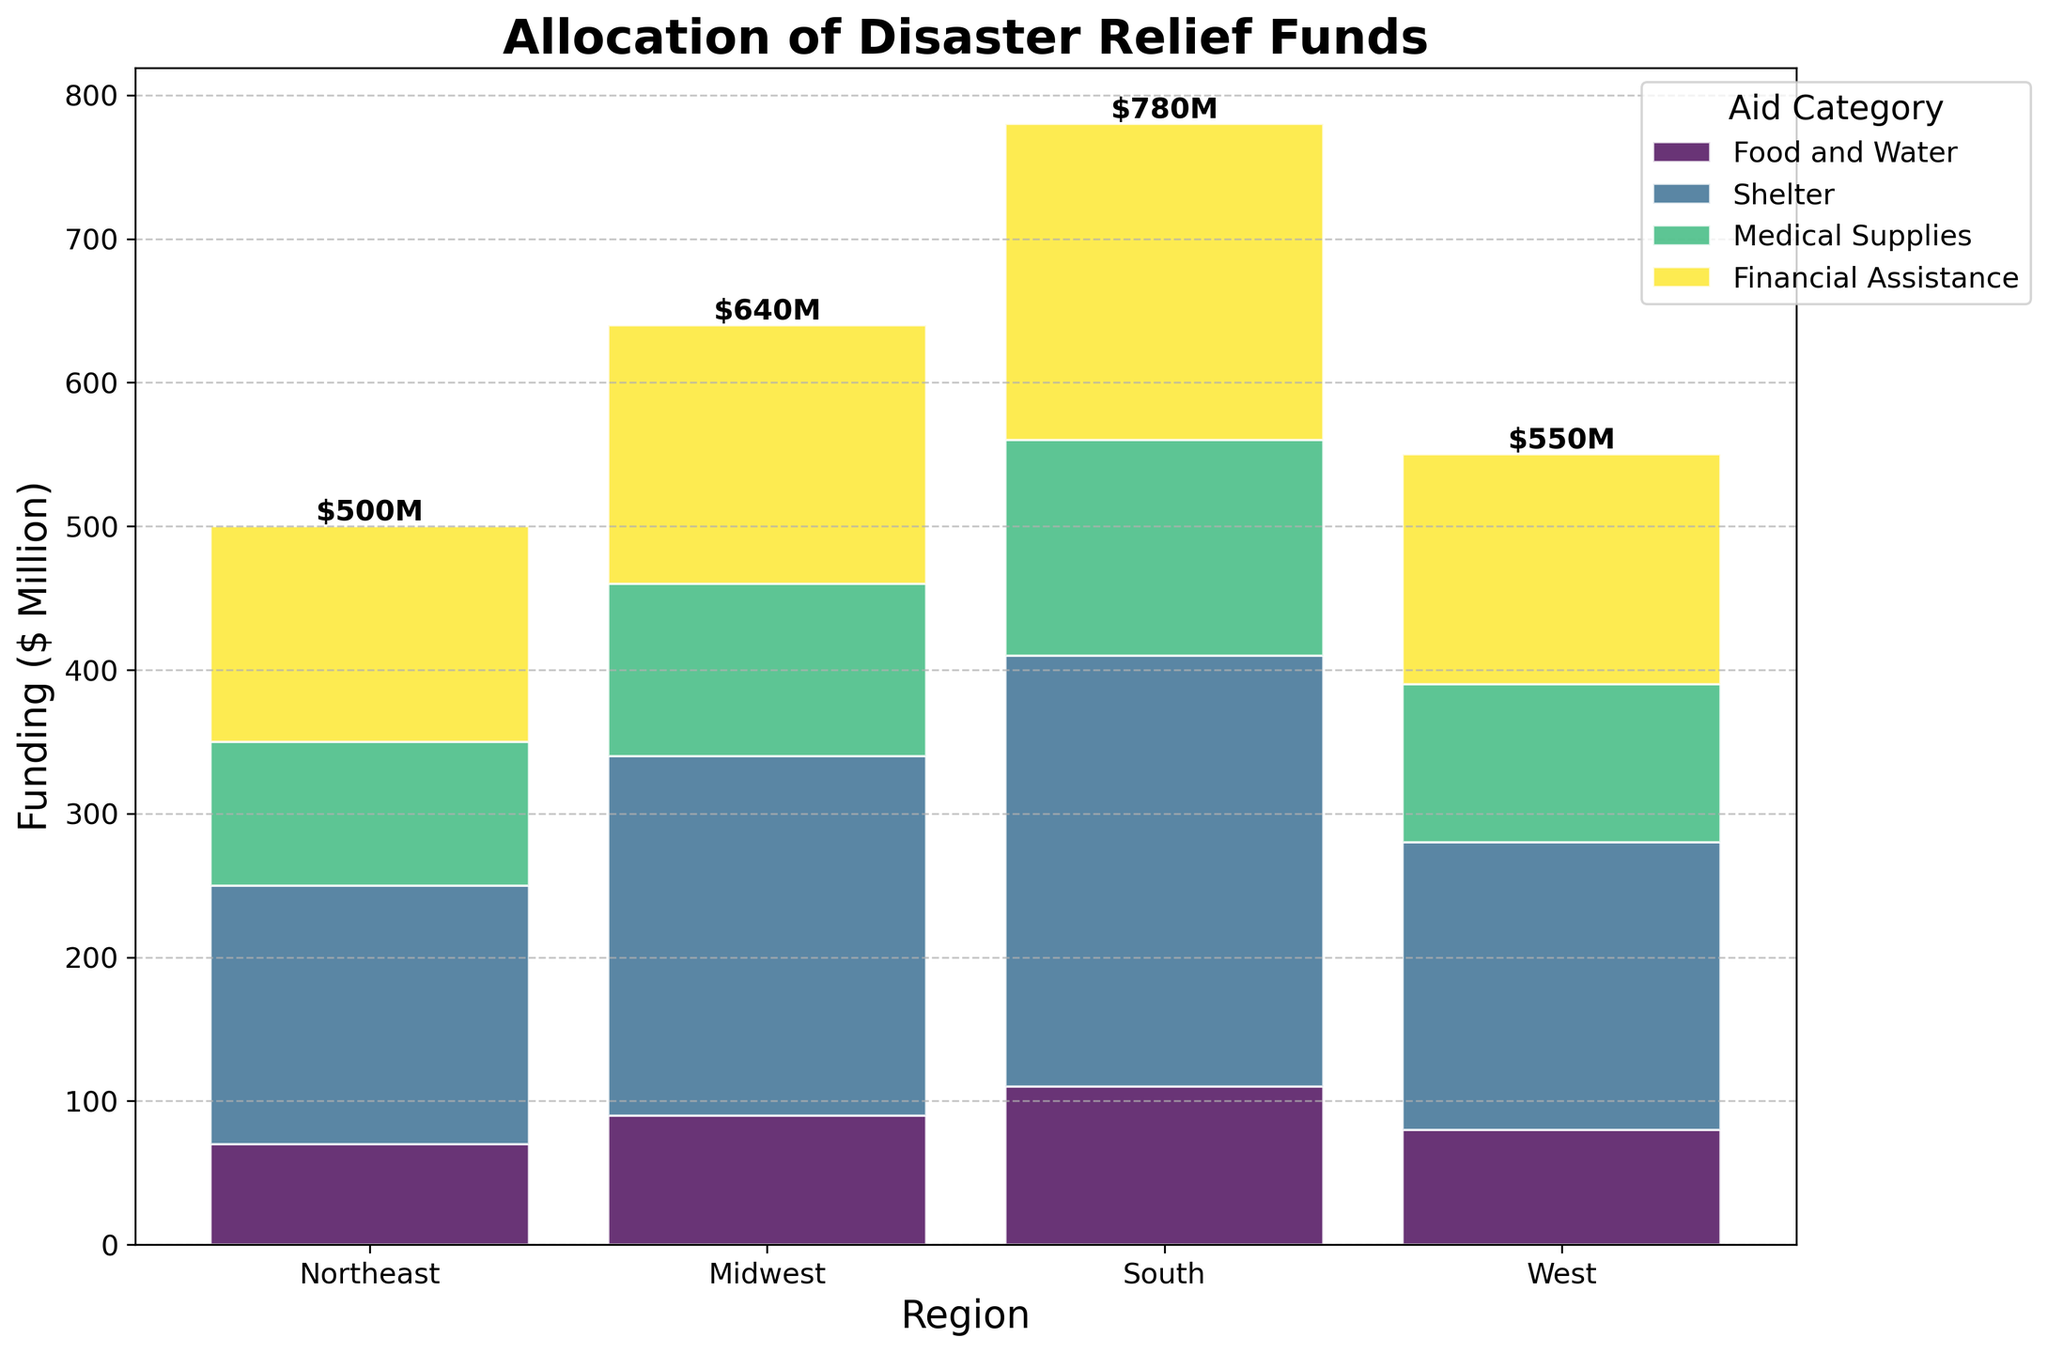What is the title of the Mosaic Plot? The title of the Mosaic Plot is often displayed at the top of the figure. In this case, it is "Allocation of Disaster Relief Funds"
Answer: Allocation of Disaster Relief Funds Which region received the most total disaster relief funds? To find this, look at the total height of all stacked bars for each region. The South has the tallest bar, indicating it received the most total funds.
Answer: South Which aid category has the highest funding in the South region? Check the segment with the largest height within the South region's bar. The segment for "Food and Water" is the largest.
Answer: Food and Water What is the total funding allocated to the Midwest region? Add up the heights of all segments in the Midwest region's bar. The amounts are 180+150+100+70=500
Answer: 500M How does the funding for Shelter in the Northeast compare to the funding for Shelter in the West? Compare the heights of the "Shelter" segments in the Northeast and West bars. The Northeast has 180M while the West has 160M.
Answer: Northeast received more Which aid category received the least amount of funding overall? Look at the smallest segments across all regions. "Financial Assistance" consistently has smaller segments compared to other categories.
Answer: Financial Assistance How does the total funding for Medical Supplies in all regions compare? Add up the Medical Supplies funding for each region: Northeast (120M), Midwest (100M), South (150M), West (110M). Total = 120+100+150+110=480
Answer: 480M By how much does the funding for Food and Water in the Northeast exceed the funding for Medical Supplies in the Midwest? Calculate the difference between the two amounts: 250M (Northeast Food and Water) - 100M (Midwest Medical Supplies) = 150M
Answer: 150M Which region has the smallest allocation for Financial Assistance, and what is that amount? Compare the "Financial Assistance" segments across regions. The Midwest has the smallest allocation, which is 70M.
Answer: Midwest, 70M 